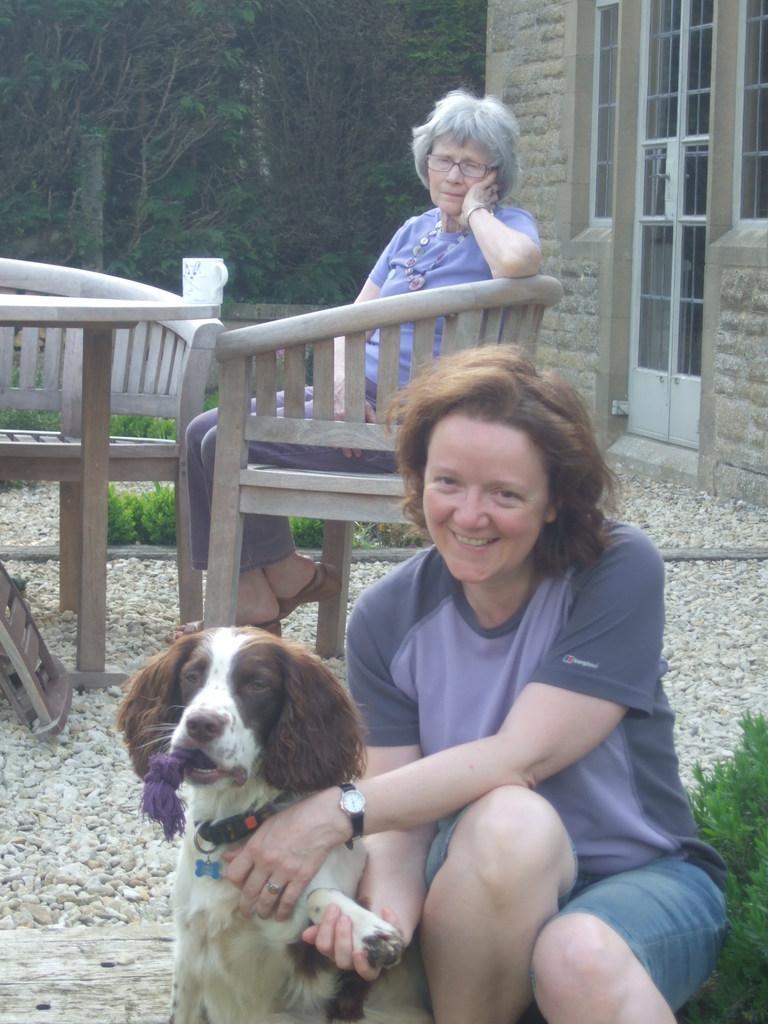How would you summarize this image in a sentence or two? In this image there are two womans and one dog. The woman is siting on the chair. There is a table. At the back side there is a building. 